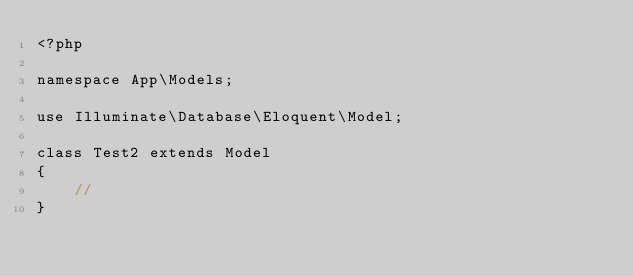<code> <loc_0><loc_0><loc_500><loc_500><_PHP_><?php

namespace App\Models;

use Illuminate\Database\Eloquent\Model;

class Test2 extends Model
{
    //
}
</code> 